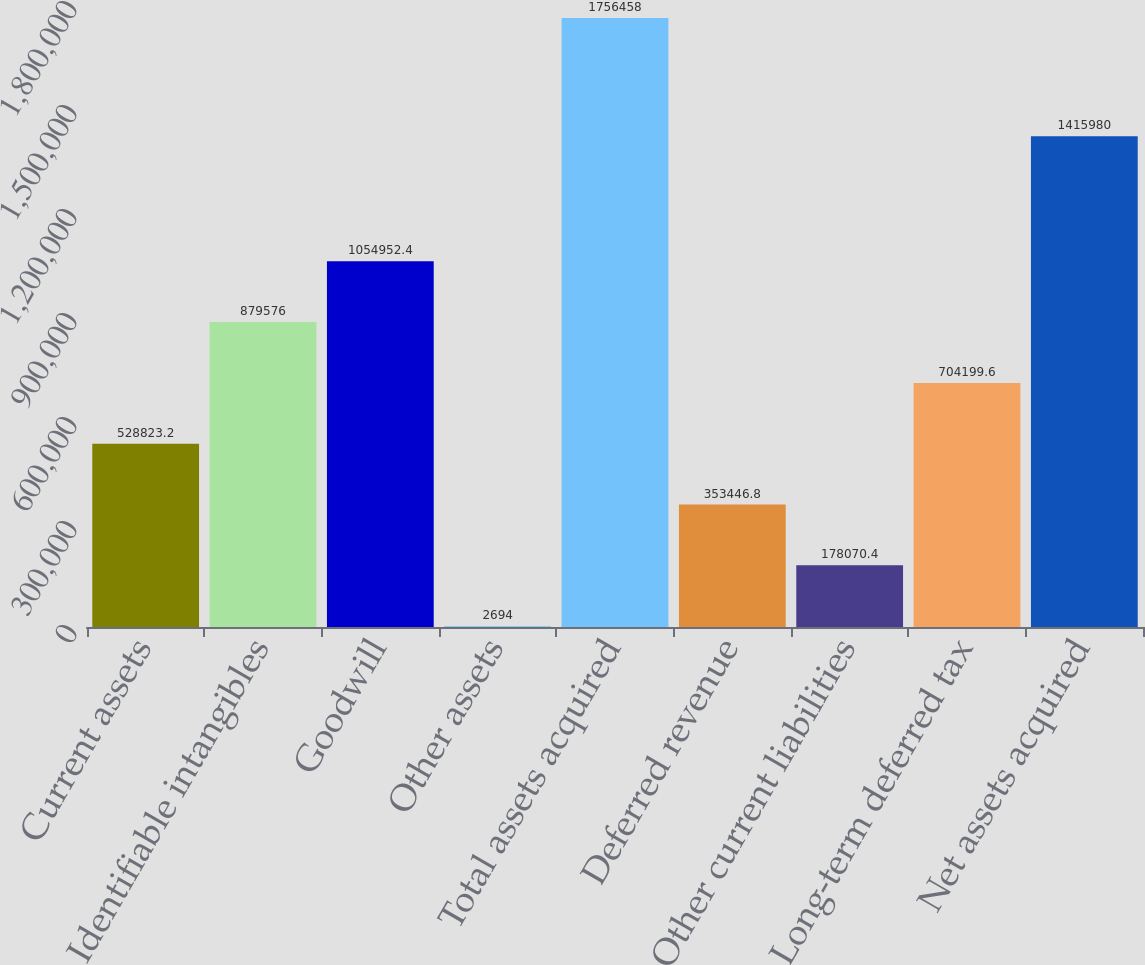Convert chart to OTSL. <chart><loc_0><loc_0><loc_500><loc_500><bar_chart><fcel>Current assets<fcel>Identifiable intangibles<fcel>Goodwill<fcel>Other assets<fcel>Total assets acquired<fcel>Deferred revenue<fcel>Other current liabilities<fcel>Long-term deferred tax<fcel>Net assets acquired<nl><fcel>528823<fcel>879576<fcel>1.05495e+06<fcel>2694<fcel>1.75646e+06<fcel>353447<fcel>178070<fcel>704200<fcel>1.41598e+06<nl></chart> 